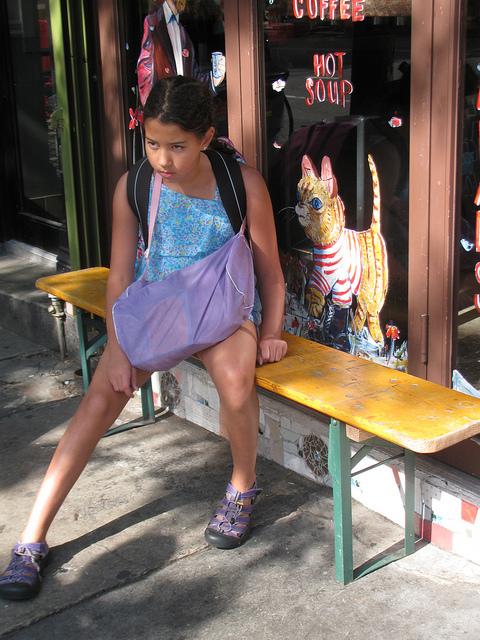How many people are sitting?
Be succinct. 1. What animal is in the picture?
Write a very short answer. Cat. What material is the bench made of?
Answer briefly. Wood. 